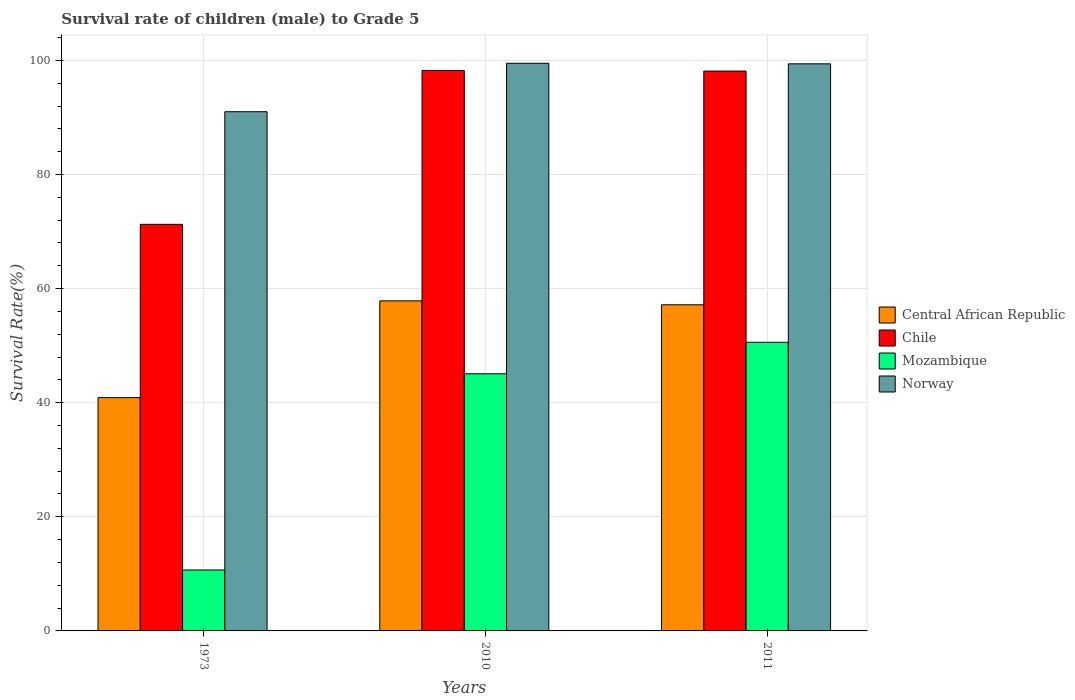How many groups of bars are there?
Your answer should be compact. 3. Are the number of bars per tick equal to the number of legend labels?
Your answer should be compact. Yes. Are the number of bars on each tick of the X-axis equal?
Your response must be concise. Yes. How many bars are there on the 3rd tick from the left?
Ensure brevity in your answer.  4. How many bars are there on the 1st tick from the right?
Give a very brief answer. 4. What is the label of the 1st group of bars from the left?
Make the answer very short. 1973. What is the survival rate of male children to grade 5 in Norway in 1973?
Offer a very short reply. 91. Across all years, what is the maximum survival rate of male children to grade 5 in Central African Republic?
Make the answer very short. 57.85. Across all years, what is the minimum survival rate of male children to grade 5 in Mozambique?
Ensure brevity in your answer.  10.68. In which year was the survival rate of male children to grade 5 in Mozambique minimum?
Give a very brief answer. 1973. What is the total survival rate of male children to grade 5 in Chile in the graph?
Provide a short and direct response. 267.62. What is the difference between the survival rate of male children to grade 5 in Norway in 2010 and that in 2011?
Your answer should be very brief. 0.1. What is the difference between the survival rate of male children to grade 5 in Norway in 2011 and the survival rate of male children to grade 5 in Central African Republic in 2010?
Give a very brief answer. 41.55. What is the average survival rate of male children to grade 5 in Norway per year?
Provide a short and direct response. 96.63. In the year 2011, what is the difference between the survival rate of male children to grade 5 in Norway and survival rate of male children to grade 5 in Central African Republic?
Offer a terse response. 42.23. In how many years, is the survival rate of male children to grade 5 in Chile greater than 68 %?
Offer a terse response. 3. What is the ratio of the survival rate of male children to grade 5 in Central African Republic in 2010 to that in 2011?
Give a very brief answer. 1.01. What is the difference between the highest and the second highest survival rate of male children to grade 5 in Norway?
Keep it short and to the point. 0.1. What is the difference between the highest and the lowest survival rate of male children to grade 5 in Central African Republic?
Offer a terse response. 16.96. What does the 3rd bar from the left in 2011 represents?
Your response must be concise. Mozambique. What does the 2nd bar from the right in 1973 represents?
Make the answer very short. Mozambique. Are all the bars in the graph horizontal?
Provide a short and direct response. No. How many years are there in the graph?
Your answer should be very brief. 3. Does the graph contain any zero values?
Ensure brevity in your answer.  No. How are the legend labels stacked?
Offer a terse response. Vertical. What is the title of the graph?
Give a very brief answer. Survival rate of children (male) to Grade 5. What is the label or title of the Y-axis?
Give a very brief answer. Survival Rate(%). What is the Survival Rate(%) of Central African Republic in 1973?
Your answer should be compact. 40.89. What is the Survival Rate(%) of Chile in 1973?
Your answer should be compact. 71.26. What is the Survival Rate(%) of Mozambique in 1973?
Your answer should be compact. 10.68. What is the Survival Rate(%) of Norway in 1973?
Offer a very short reply. 91. What is the Survival Rate(%) in Central African Republic in 2010?
Ensure brevity in your answer.  57.85. What is the Survival Rate(%) in Chile in 2010?
Keep it short and to the point. 98.23. What is the Survival Rate(%) in Mozambique in 2010?
Make the answer very short. 45.07. What is the Survival Rate(%) of Norway in 2010?
Keep it short and to the point. 99.49. What is the Survival Rate(%) of Central African Republic in 2011?
Make the answer very short. 57.16. What is the Survival Rate(%) in Chile in 2011?
Provide a short and direct response. 98.12. What is the Survival Rate(%) in Mozambique in 2011?
Provide a short and direct response. 50.59. What is the Survival Rate(%) in Norway in 2011?
Your answer should be compact. 99.39. Across all years, what is the maximum Survival Rate(%) in Central African Republic?
Ensure brevity in your answer.  57.85. Across all years, what is the maximum Survival Rate(%) of Chile?
Ensure brevity in your answer.  98.23. Across all years, what is the maximum Survival Rate(%) of Mozambique?
Ensure brevity in your answer.  50.59. Across all years, what is the maximum Survival Rate(%) in Norway?
Provide a succinct answer. 99.49. Across all years, what is the minimum Survival Rate(%) in Central African Republic?
Provide a short and direct response. 40.89. Across all years, what is the minimum Survival Rate(%) in Chile?
Provide a short and direct response. 71.26. Across all years, what is the minimum Survival Rate(%) in Mozambique?
Offer a terse response. 10.68. Across all years, what is the minimum Survival Rate(%) of Norway?
Offer a very short reply. 91. What is the total Survival Rate(%) in Central African Republic in the graph?
Make the answer very short. 155.9. What is the total Survival Rate(%) of Chile in the graph?
Your answer should be compact. 267.62. What is the total Survival Rate(%) in Mozambique in the graph?
Ensure brevity in your answer.  106.34. What is the total Survival Rate(%) of Norway in the graph?
Your response must be concise. 289.88. What is the difference between the Survival Rate(%) of Central African Republic in 1973 and that in 2010?
Make the answer very short. -16.96. What is the difference between the Survival Rate(%) of Chile in 1973 and that in 2010?
Give a very brief answer. -26.97. What is the difference between the Survival Rate(%) of Mozambique in 1973 and that in 2010?
Your response must be concise. -34.39. What is the difference between the Survival Rate(%) in Norway in 1973 and that in 2010?
Offer a terse response. -8.5. What is the difference between the Survival Rate(%) of Central African Republic in 1973 and that in 2011?
Your answer should be compact. -16.27. What is the difference between the Survival Rate(%) of Chile in 1973 and that in 2011?
Your answer should be compact. -26.86. What is the difference between the Survival Rate(%) of Mozambique in 1973 and that in 2011?
Keep it short and to the point. -39.91. What is the difference between the Survival Rate(%) in Norway in 1973 and that in 2011?
Ensure brevity in your answer.  -8.4. What is the difference between the Survival Rate(%) of Central African Republic in 2010 and that in 2011?
Give a very brief answer. 0.69. What is the difference between the Survival Rate(%) of Chile in 2010 and that in 2011?
Ensure brevity in your answer.  0.11. What is the difference between the Survival Rate(%) in Mozambique in 2010 and that in 2011?
Your answer should be very brief. -5.52. What is the difference between the Survival Rate(%) of Norway in 2010 and that in 2011?
Your response must be concise. 0.1. What is the difference between the Survival Rate(%) in Central African Republic in 1973 and the Survival Rate(%) in Chile in 2010?
Provide a succinct answer. -57.34. What is the difference between the Survival Rate(%) of Central African Republic in 1973 and the Survival Rate(%) of Mozambique in 2010?
Your response must be concise. -4.18. What is the difference between the Survival Rate(%) in Central African Republic in 1973 and the Survival Rate(%) in Norway in 2010?
Provide a short and direct response. -58.6. What is the difference between the Survival Rate(%) in Chile in 1973 and the Survival Rate(%) in Mozambique in 2010?
Provide a succinct answer. 26.19. What is the difference between the Survival Rate(%) of Chile in 1973 and the Survival Rate(%) of Norway in 2010?
Ensure brevity in your answer.  -28.23. What is the difference between the Survival Rate(%) in Mozambique in 1973 and the Survival Rate(%) in Norway in 2010?
Provide a succinct answer. -88.81. What is the difference between the Survival Rate(%) of Central African Republic in 1973 and the Survival Rate(%) of Chile in 2011?
Give a very brief answer. -57.23. What is the difference between the Survival Rate(%) of Central African Republic in 1973 and the Survival Rate(%) of Mozambique in 2011?
Ensure brevity in your answer.  -9.7. What is the difference between the Survival Rate(%) of Central African Republic in 1973 and the Survival Rate(%) of Norway in 2011?
Offer a very short reply. -58.5. What is the difference between the Survival Rate(%) in Chile in 1973 and the Survival Rate(%) in Mozambique in 2011?
Provide a short and direct response. 20.67. What is the difference between the Survival Rate(%) in Chile in 1973 and the Survival Rate(%) in Norway in 2011?
Provide a short and direct response. -28.13. What is the difference between the Survival Rate(%) of Mozambique in 1973 and the Survival Rate(%) of Norway in 2011?
Offer a terse response. -88.71. What is the difference between the Survival Rate(%) in Central African Republic in 2010 and the Survival Rate(%) in Chile in 2011?
Your answer should be compact. -40.28. What is the difference between the Survival Rate(%) of Central African Republic in 2010 and the Survival Rate(%) of Mozambique in 2011?
Ensure brevity in your answer.  7.26. What is the difference between the Survival Rate(%) in Central African Republic in 2010 and the Survival Rate(%) in Norway in 2011?
Give a very brief answer. -41.55. What is the difference between the Survival Rate(%) of Chile in 2010 and the Survival Rate(%) of Mozambique in 2011?
Ensure brevity in your answer.  47.64. What is the difference between the Survival Rate(%) of Chile in 2010 and the Survival Rate(%) of Norway in 2011?
Keep it short and to the point. -1.16. What is the difference between the Survival Rate(%) in Mozambique in 2010 and the Survival Rate(%) in Norway in 2011?
Your answer should be very brief. -54.32. What is the average Survival Rate(%) in Central African Republic per year?
Make the answer very short. 51.97. What is the average Survival Rate(%) of Chile per year?
Provide a succinct answer. 89.21. What is the average Survival Rate(%) in Mozambique per year?
Offer a terse response. 35.45. What is the average Survival Rate(%) in Norway per year?
Your response must be concise. 96.63. In the year 1973, what is the difference between the Survival Rate(%) of Central African Republic and Survival Rate(%) of Chile?
Your response must be concise. -30.37. In the year 1973, what is the difference between the Survival Rate(%) in Central African Republic and Survival Rate(%) in Mozambique?
Make the answer very short. 30.21. In the year 1973, what is the difference between the Survival Rate(%) in Central African Republic and Survival Rate(%) in Norway?
Offer a very short reply. -50.11. In the year 1973, what is the difference between the Survival Rate(%) of Chile and Survival Rate(%) of Mozambique?
Offer a very short reply. 60.58. In the year 1973, what is the difference between the Survival Rate(%) of Chile and Survival Rate(%) of Norway?
Keep it short and to the point. -19.74. In the year 1973, what is the difference between the Survival Rate(%) of Mozambique and Survival Rate(%) of Norway?
Provide a succinct answer. -80.32. In the year 2010, what is the difference between the Survival Rate(%) in Central African Republic and Survival Rate(%) in Chile?
Your answer should be very brief. -40.38. In the year 2010, what is the difference between the Survival Rate(%) of Central African Republic and Survival Rate(%) of Mozambique?
Make the answer very short. 12.78. In the year 2010, what is the difference between the Survival Rate(%) of Central African Republic and Survival Rate(%) of Norway?
Ensure brevity in your answer.  -41.65. In the year 2010, what is the difference between the Survival Rate(%) in Chile and Survival Rate(%) in Mozambique?
Offer a terse response. 53.16. In the year 2010, what is the difference between the Survival Rate(%) in Chile and Survival Rate(%) in Norway?
Offer a very short reply. -1.26. In the year 2010, what is the difference between the Survival Rate(%) in Mozambique and Survival Rate(%) in Norway?
Ensure brevity in your answer.  -54.42. In the year 2011, what is the difference between the Survival Rate(%) of Central African Republic and Survival Rate(%) of Chile?
Provide a succinct answer. -40.96. In the year 2011, what is the difference between the Survival Rate(%) in Central African Republic and Survival Rate(%) in Mozambique?
Give a very brief answer. 6.57. In the year 2011, what is the difference between the Survival Rate(%) in Central African Republic and Survival Rate(%) in Norway?
Ensure brevity in your answer.  -42.23. In the year 2011, what is the difference between the Survival Rate(%) of Chile and Survival Rate(%) of Mozambique?
Keep it short and to the point. 47.54. In the year 2011, what is the difference between the Survival Rate(%) of Chile and Survival Rate(%) of Norway?
Make the answer very short. -1.27. In the year 2011, what is the difference between the Survival Rate(%) in Mozambique and Survival Rate(%) in Norway?
Your answer should be very brief. -48.81. What is the ratio of the Survival Rate(%) in Central African Republic in 1973 to that in 2010?
Make the answer very short. 0.71. What is the ratio of the Survival Rate(%) of Chile in 1973 to that in 2010?
Ensure brevity in your answer.  0.73. What is the ratio of the Survival Rate(%) in Mozambique in 1973 to that in 2010?
Your response must be concise. 0.24. What is the ratio of the Survival Rate(%) of Norway in 1973 to that in 2010?
Offer a terse response. 0.91. What is the ratio of the Survival Rate(%) of Central African Republic in 1973 to that in 2011?
Offer a very short reply. 0.72. What is the ratio of the Survival Rate(%) in Chile in 1973 to that in 2011?
Give a very brief answer. 0.73. What is the ratio of the Survival Rate(%) of Mozambique in 1973 to that in 2011?
Give a very brief answer. 0.21. What is the ratio of the Survival Rate(%) in Norway in 1973 to that in 2011?
Give a very brief answer. 0.92. What is the ratio of the Survival Rate(%) in Central African Republic in 2010 to that in 2011?
Your answer should be compact. 1.01. What is the ratio of the Survival Rate(%) of Chile in 2010 to that in 2011?
Your answer should be very brief. 1. What is the ratio of the Survival Rate(%) of Mozambique in 2010 to that in 2011?
Your answer should be very brief. 0.89. What is the ratio of the Survival Rate(%) in Norway in 2010 to that in 2011?
Provide a short and direct response. 1. What is the difference between the highest and the second highest Survival Rate(%) in Central African Republic?
Offer a terse response. 0.69. What is the difference between the highest and the second highest Survival Rate(%) in Chile?
Give a very brief answer. 0.11. What is the difference between the highest and the second highest Survival Rate(%) of Mozambique?
Your response must be concise. 5.52. What is the difference between the highest and the second highest Survival Rate(%) in Norway?
Give a very brief answer. 0.1. What is the difference between the highest and the lowest Survival Rate(%) in Central African Republic?
Your response must be concise. 16.96. What is the difference between the highest and the lowest Survival Rate(%) in Chile?
Give a very brief answer. 26.97. What is the difference between the highest and the lowest Survival Rate(%) in Mozambique?
Provide a succinct answer. 39.91. What is the difference between the highest and the lowest Survival Rate(%) in Norway?
Your answer should be compact. 8.5. 